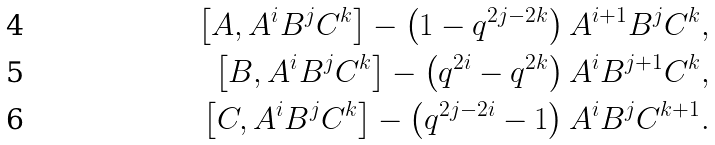Convert formula to latex. <formula><loc_0><loc_0><loc_500><loc_500>\left [ A , A ^ { i } B ^ { j } C ^ { k } \right ] - \left ( 1 - q ^ { 2 j - 2 k } \right ) A ^ { i + 1 } B ^ { j } C ^ { k } , \\ \left [ B , A ^ { i } B ^ { j } C ^ { k } \right ] - \left ( q ^ { 2 i } - q ^ { 2 k } \right ) A ^ { i } B ^ { j + 1 } C ^ { k } , \\ \left [ C , A ^ { i } B ^ { j } C ^ { k } \right ] - \left ( q ^ { 2 j - 2 i } - 1 \right ) A ^ { i } B ^ { j } C ^ { k + 1 } .</formula> 